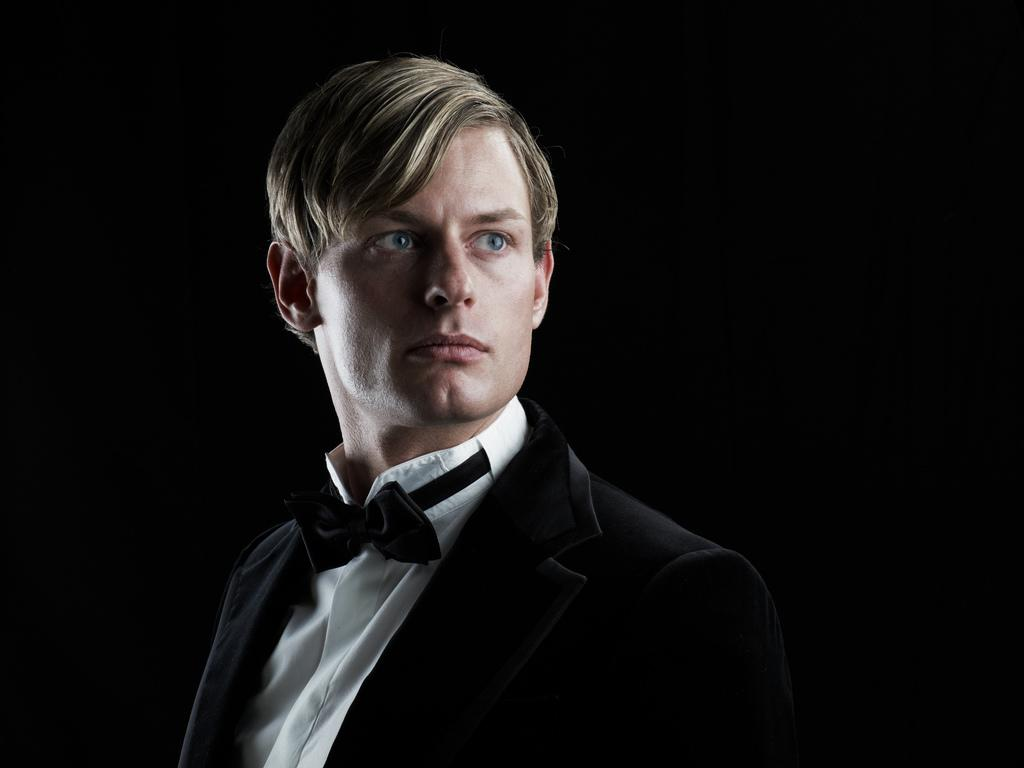Who is present in the image? There is a man in the image. What is the man doing in the image? The man is present over a place. What is the man wearing on his upper body? The man is wearing a black-colored coat. What accessory is the man wearing around his neck? The man is wearing a bow tie on his neck. What type of glass is the man holding in the image? There is no glass present in the image; the man is wearing a bow tie and a black-colored coat. 